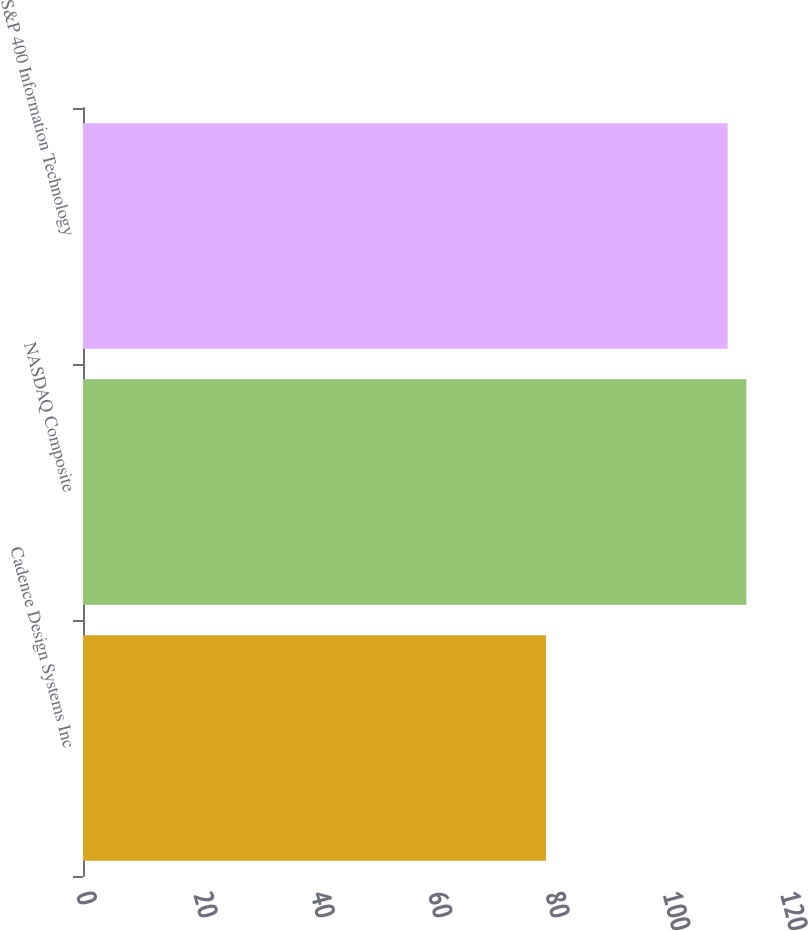Convert chart. <chart><loc_0><loc_0><loc_500><loc_500><bar_chart><fcel>Cadence Design Systems Inc<fcel>NASDAQ Composite<fcel>S&P 400 Information Technology<nl><fcel>78.92<fcel>113.07<fcel>109.88<nl></chart> 